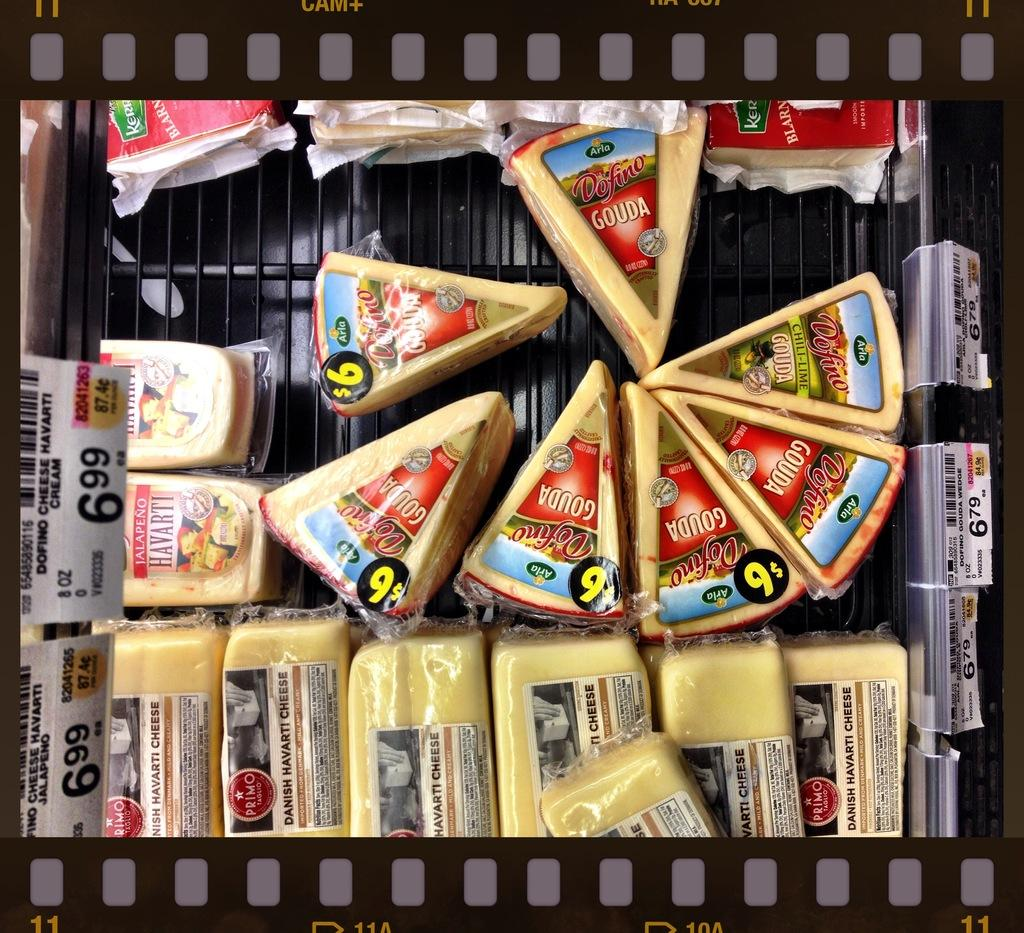<image>
Describe the image concisely. A collection of cheeses including Gouda and Havarti. 